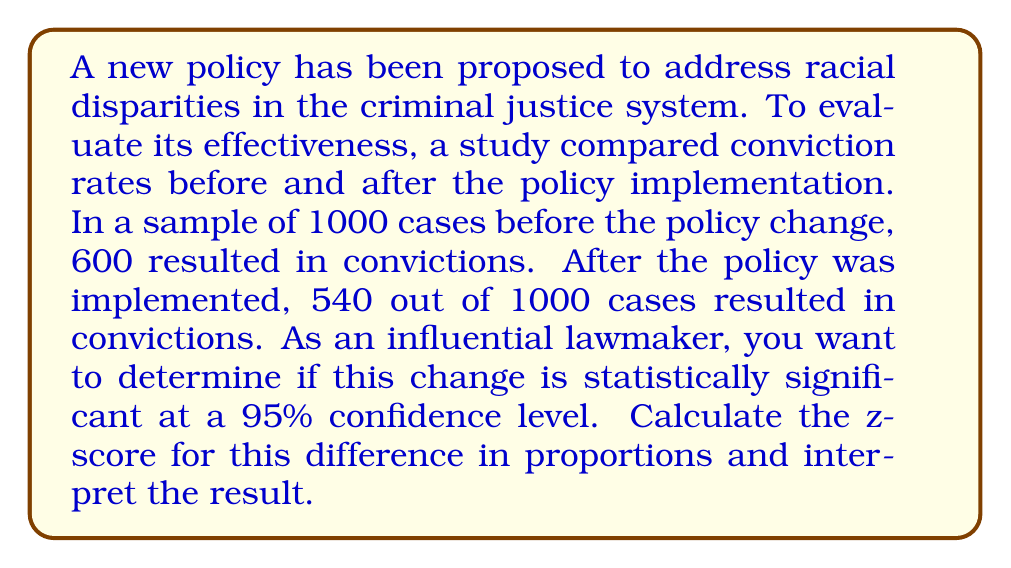Give your solution to this math problem. To determine if the change in conviction rates is statistically significant, we'll use a two-proportion z-test. Here's the step-by-step process:

1. Define the null and alternative hypotheses:
   $H_0: p_1 = p_2$ (no difference in proportions)
   $H_a: p_1 \neq p_2$ (there is a difference in proportions)

2. Calculate the pooled proportion:
   $$p = \frac{x_1 + x_2}{n_1 + n_2} = \frac{600 + 540}{1000 + 1000} = \frac{1140}{2000} = 0.57$$

3. Calculate the standard error:
   $$SE = \sqrt{p(1-p)(\frac{1}{n_1} + \frac{1}{n_2})} = \sqrt{0.57(1-0.57)(\frac{1}{1000} + \frac{1}{1000})} = 0.0222$$

4. Calculate the z-score:
   $$z = \frac{(p_1 - p_2) - 0}{SE} = \frac{(0.6 - 0.54) - 0}{0.0222} = 2.70$$

5. Interpret the result:
   At a 95% confidence level, the critical z-value is ±1.96. Since our calculated z-score (2.70) is greater than 1.96, we reject the null hypothesis.

This means the change in conviction rates is statistically significant at the 95% confidence level. The decrease from 60% to 54% is unlikely to have occurred by chance alone.

As an influential lawmaker cautious about policy changes impacting conviction rates, this result suggests that the new policy has indeed led to a significant decrease in conviction rates. This information should be carefully considered when evaluating the policy's overall impact and effectiveness.
Answer: The z-score is 2.70, which is greater than the critical value of 1.96 at the 95% confidence level. Therefore, the change in conviction rates is statistically significant. 